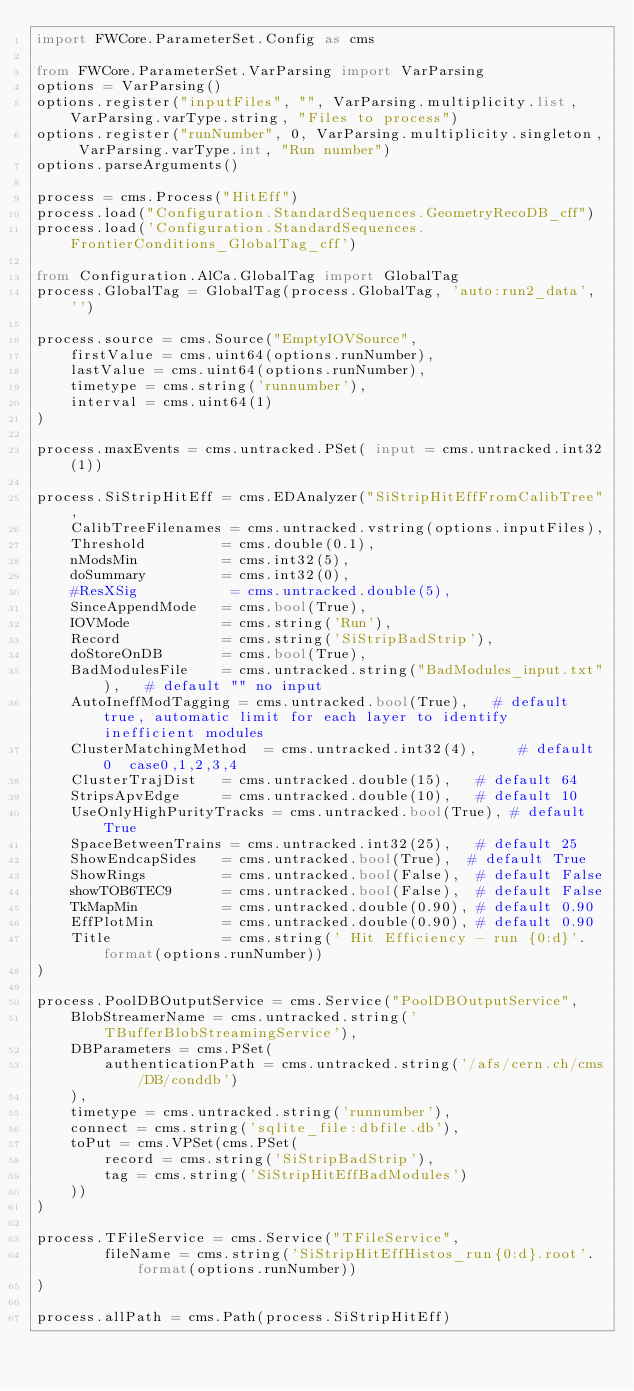Convert code to text. <code><loc_0><loc_0><loc_500><loc_500><_Python_>import FWCore.ParameterSet.Config as cms

from FWCore.ParameterSet.VarParsing import VarParsing
options = VarParsing()
options.register("inputFiles", "", VarParsing.multiplicity.list, VarParsing.varType.string, "Files to process")
options.register("runNumber", 0, VarParsing.multiplicity.singleton, VarParsing.varType.int, "Run number")
options.parseArguments()

process = cms.Process("HitEff")
process.load("Configuration.StandardSequences.GeometryRecoDB_cff")
process.load('Configuration.StandardSequences.FrontierConditions_GlobalTag_cff')

from Configuration.AlCa.GlobalTag import GlobalTag
process.GlobalTag = GlobalTag(process.GlobalTag, 'auto:run2_data', '')  

process.source = cms.Source("EmptyIOVSource",
    firstValue = cms.uint64(options.runNumber),
    lastValue = cms.uint64(options.runNumber),
    timetype = cms.string('runnumber'),
    interval = cms.uint64(1)
)

process.maxEvents = cms.untracked.PSet( input = cms.untracked.int32(1))

process.SiStripHitEff = cms.EDAnalyzer("SiStripHitEffFromCalibTree",
    CalibTreeFilenames = cms.untracked.vstring(options.inputFiles),
    Threshold         = cms.double(0.1),
    nModsMin          = cms.int32(5),
    doSummary         = cms.int32(0),
    #ResXSig           = cms.untracked.double(5),
    SinceAppendMode   = cms.bool(True),
    IOVMode           = cms.string('Run'),
    Record            = cms.string('SiStripBadStrip'),
    doStoreOnDB       = cms.bool(True),
    BadModulesFile    = cms.untracked.string("BadModules_input.txt"),   # default "" no input
    AutoIneffModTagging = cms.untracked.bool(True),   # default true, automatic limit for each layer to identify inefficient modules
    ClusterMatchingMethod  = cms.untracked.int32(4),     # default 0  case0,1,2,3,4
    ClusterTrajDist   = cms.untracked.double(15),   # default 64
    StripsApvEdge     = cms.untracked.double(10),   # default 10  
    UseOnlyHighPurityTracks = cms.untracked.bool(True), # default True
    SpaceBetweenTrains = cms.untracked.int32(25),   # default 25
    ShowEndcapSides   = cms.untracked.bool(True),  # default True
    ShowRings         = cms.untracked.bool(False),  # default False
    showTOB6TEC9      = cms.untracked.bool(False),  # default False
    TkMapMin          = cms.untracked.double(0.90), # default 0.90
    EffPlotMin        = cms.untracked.double(0.90), # default 0.90
    Title             = cms.string(' Hit Efficiency - run {0:d}'.format(options.runNumber))
)

process.PoolDBOutputService = cms.Service("PoolDBOutputService",
    BlobStreamerName = cms.untracked.string('TBufferBlobStreamingService'),
    DBParameters = cms.PSet(
        authenticationPath = cms.untracked.string('/afs/cern.ch/cms/DB/conddb')
    ),
    timetype = cms.untracked.string('runnumber'),
    connect = cms.string('sqlite_file:dbfile.db'),
    toPut = cms.VPSet(cms.PSet(
        record = cms.string('SiStripBadStrip'),
        tag = cms.string('SiStripHitEffBadModules')
    ))
)

process.TFileService = cms.Service("TFileService",
        fileName = cms.string('SiStripHitEffHistos_run{0:d}.root'.format(options.runNumber))
)

process.allPath = cms.Path(process.SiStripHitEff)
</code> 